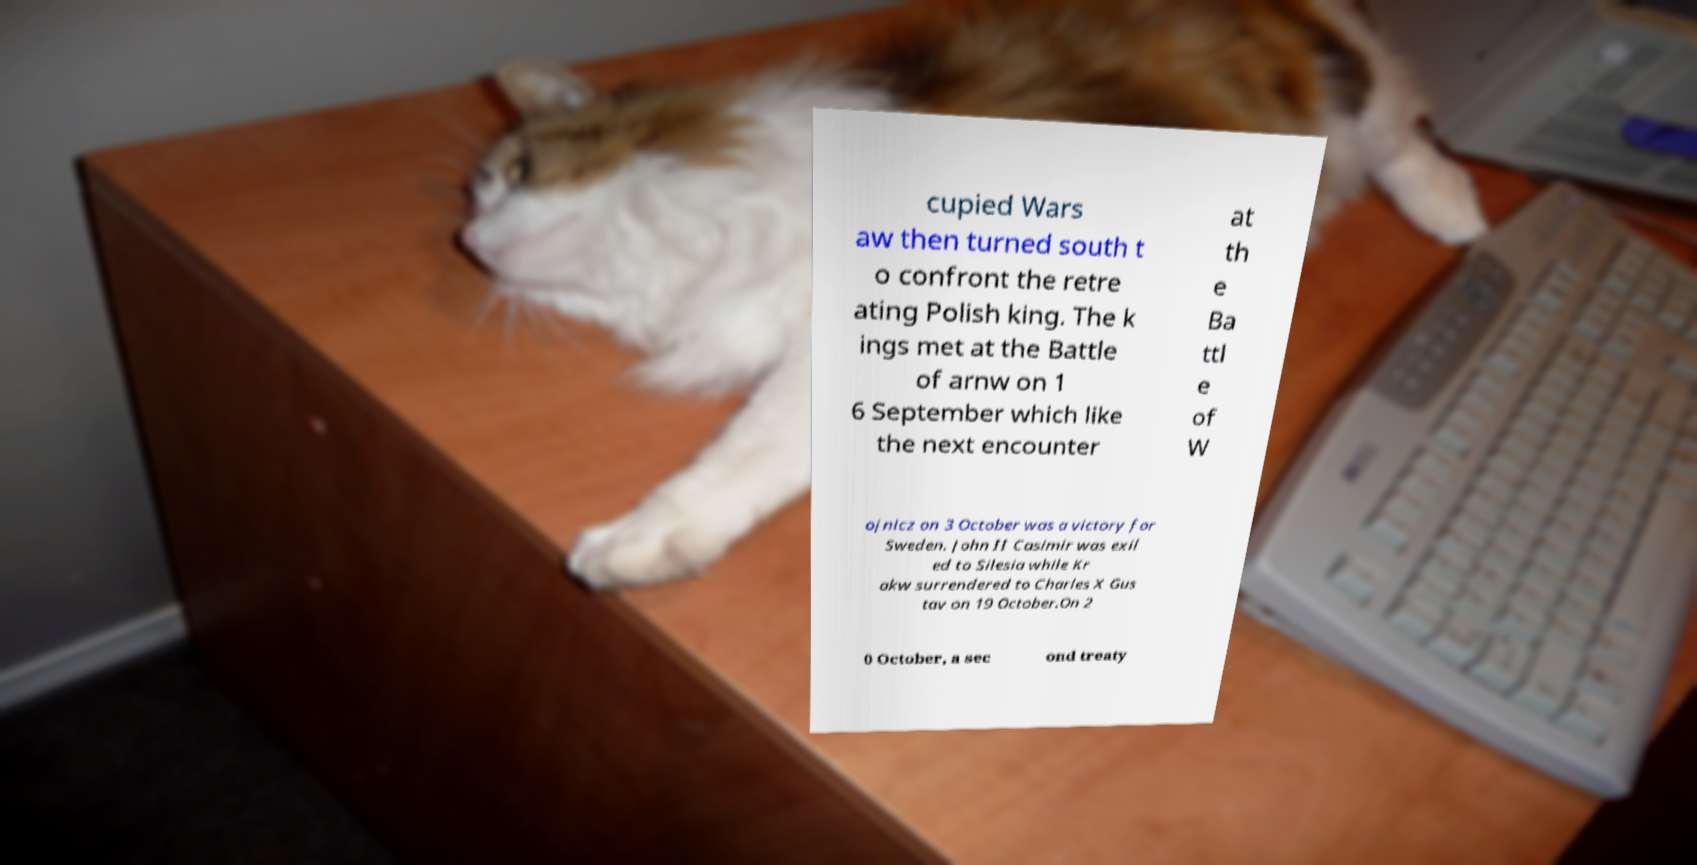Could you assist in decoding the text presented in this image and type it out clearly? cupied Wars aw then turned south t o confront the retre ating Polish king. The k ings met at the Battle of arnw on 1 6 September which like the next encounter at th e Ba ttl e of W ojnicz on 3 October was a victory for Sweden. John II Casimir was exil ed to Silesia while Kr akw surrendered to Charles X Gus tav on 19 October.On 2 0 October, a sec ond treaty 